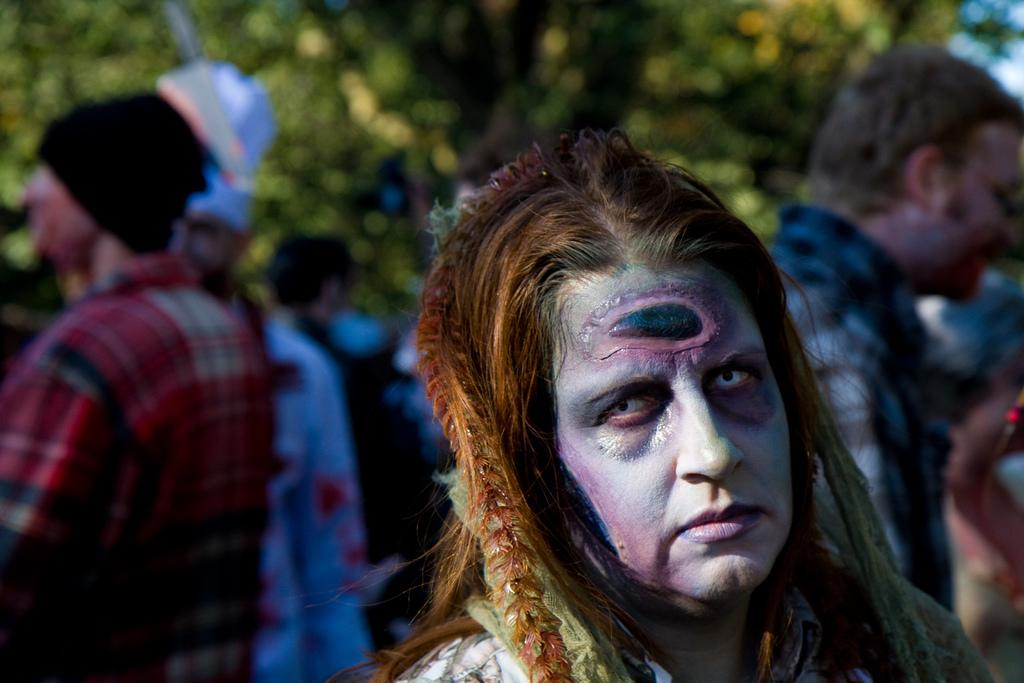Who or what can be seen in the image? There are people in the image. What can be seen in the background of the image? There are leaves in the background of the image. How would you describe the background of the image? The background of the image is blurry. Is there a stream visible in the image? No, there is no stream present in the image. Can you see a tent in the image? No, there is no tent present in the image. 